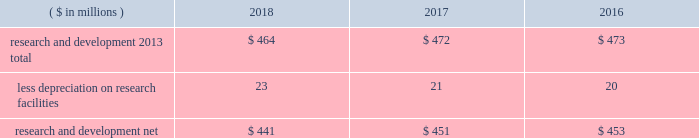52 2018 ppg annual report and 10-k 1 .
Summary of significant accounting policies principles of consolidation the accompanying consolidated financial statements include the accounts of ppg industries , inc .
( 201cppg 201d or the 201ccompany 201d ) and all subsidiaries , both u.s .
And non-u.s. , that it controls .
Ppg owns more than 50% ( 50 % ) of the voting stock of most of the subsidiaries that it controls .
For those consolidated subsidiaries in which the company 2019s ownership is less than 100% ( 100 % ) , the outside shareholders 2019 interests are shown as noncontrolling interests .
Investments in companies in which ppg owns 20% ( 20 % ) to 50% ( 50 % ) of the voting stock and has the ability to exercise significant influence over operating and financial policies of the investee are accounted for using the equity method of accounting .
As a result , ppg 2019s share of income or losses from such equity affiliates is included in the consolidated statement of income and ppg 2019s share of these companies 2019 shareholders 2019 equity is included in investments on the consolidated balance sheet .
Transactions between ppg and its subsidiaries are eliminated in consolidation .
Use of estimates in the preparation of financial statements the preparation of financial statements in conformity with u.s .
Generally accepted accounting principles requires management to make estimates and assumptions that affect the reported amounts of assets and liabilities and the disclosure of contingent assets and liabilities at the date of the financial statements , as well as the reported amounts of income and expenses during the reporting period .
Such estimates also include the fair value of assets acquired and liabilities assumed resulting from the allocation of the purchase price related to business combinations consummated .
Actual outcomes could differ from those estimates .
Revenue recognition revenue is recognized as performance obligations with the customer are satisfied , at an amount that is determined to be collectible .
For the sale of products , this generally occurs at the point in time when control of the company 2019s products transfers to the customer based on the agreed upon shipping terms .
Shipping and handling costs amounts billed to customers for shipping and handling are reported in net sales in the consolidated statement of income .
Shipping and handling costs incurred by the company for the delivery of goods to customers are included in cost of sales , exclusive of depreciation and amortization in the consolidated statement of income .
Selling , general and administrative costs amounts presented in selling , general and administrative in the consolidated statement of income are comprised of selling , customer service , distribution and advertising costs , as well as the costs of providing corporate-wide functional support in such areas as finance , law , human resources and planning .
Distribution costs pertain to the movement and storage of finished goods inventory at company-owned and leased warehouses and other distribution facilities .
Advertising costs advertising costs are expensed as incurred and totaled $ 280 million , $ 313 million and $ 322 million in 2018 , 2017 and 2016 , respectively .
Research and development research and development costs , which consist primarily of employee related costs , are charged to expense as incurred. .
Legal costs legal costs , primarily include costs associated with acquisition and divestiture transactions , general litigation , environmental regulation compliance , patent and trademark protection and other general corporate purposes , are charged to expense as incurred .
Income taxes income taxes are accounted for under the asset and liability method .
Deferred tax assets and liabilities are recognized for the future tax consequences attributable to operating losses and tax credit carryforwards as well as differences between the financial statement carrying amounts of existing assets and liabilities and their respective tax bases .
The effect on deferred notes to the consolidated financial statements .
What was the change in research and development net in millions from 2017 to 2018? 
Computations: (441 - 451)
Answer: -10.0. 